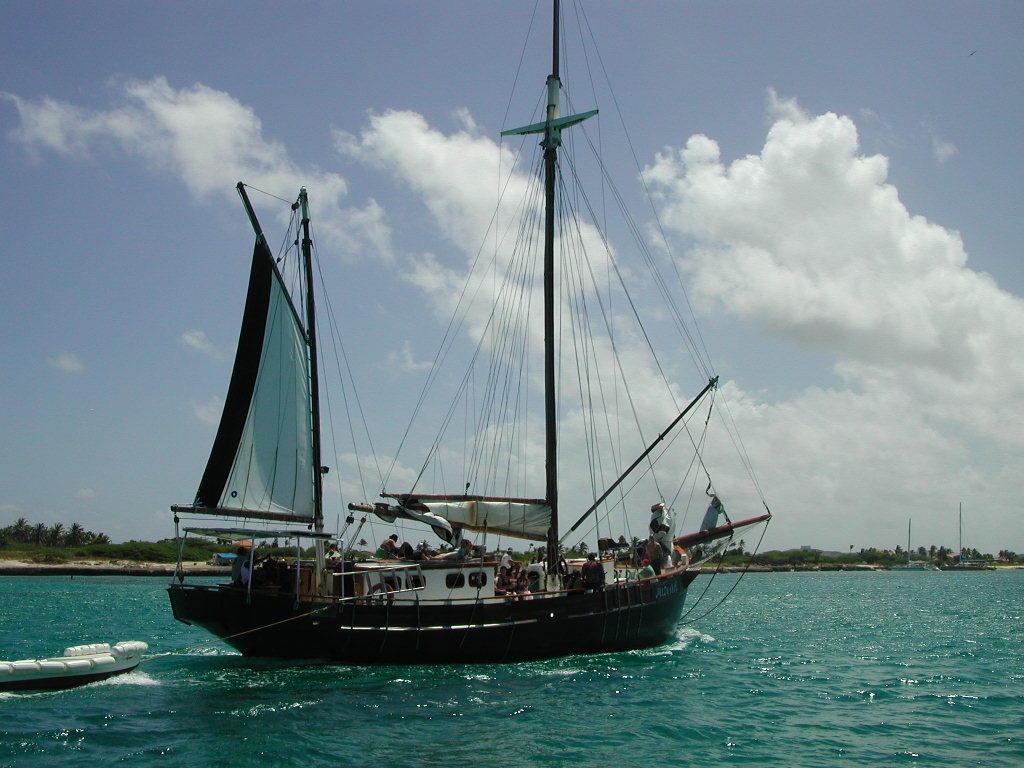Describe this image in one or two sentences. In this image, we can see some people on the ship and in the background, there are trees and hills. At the top, there are clouds in the sky and at the bottom, there is water. 